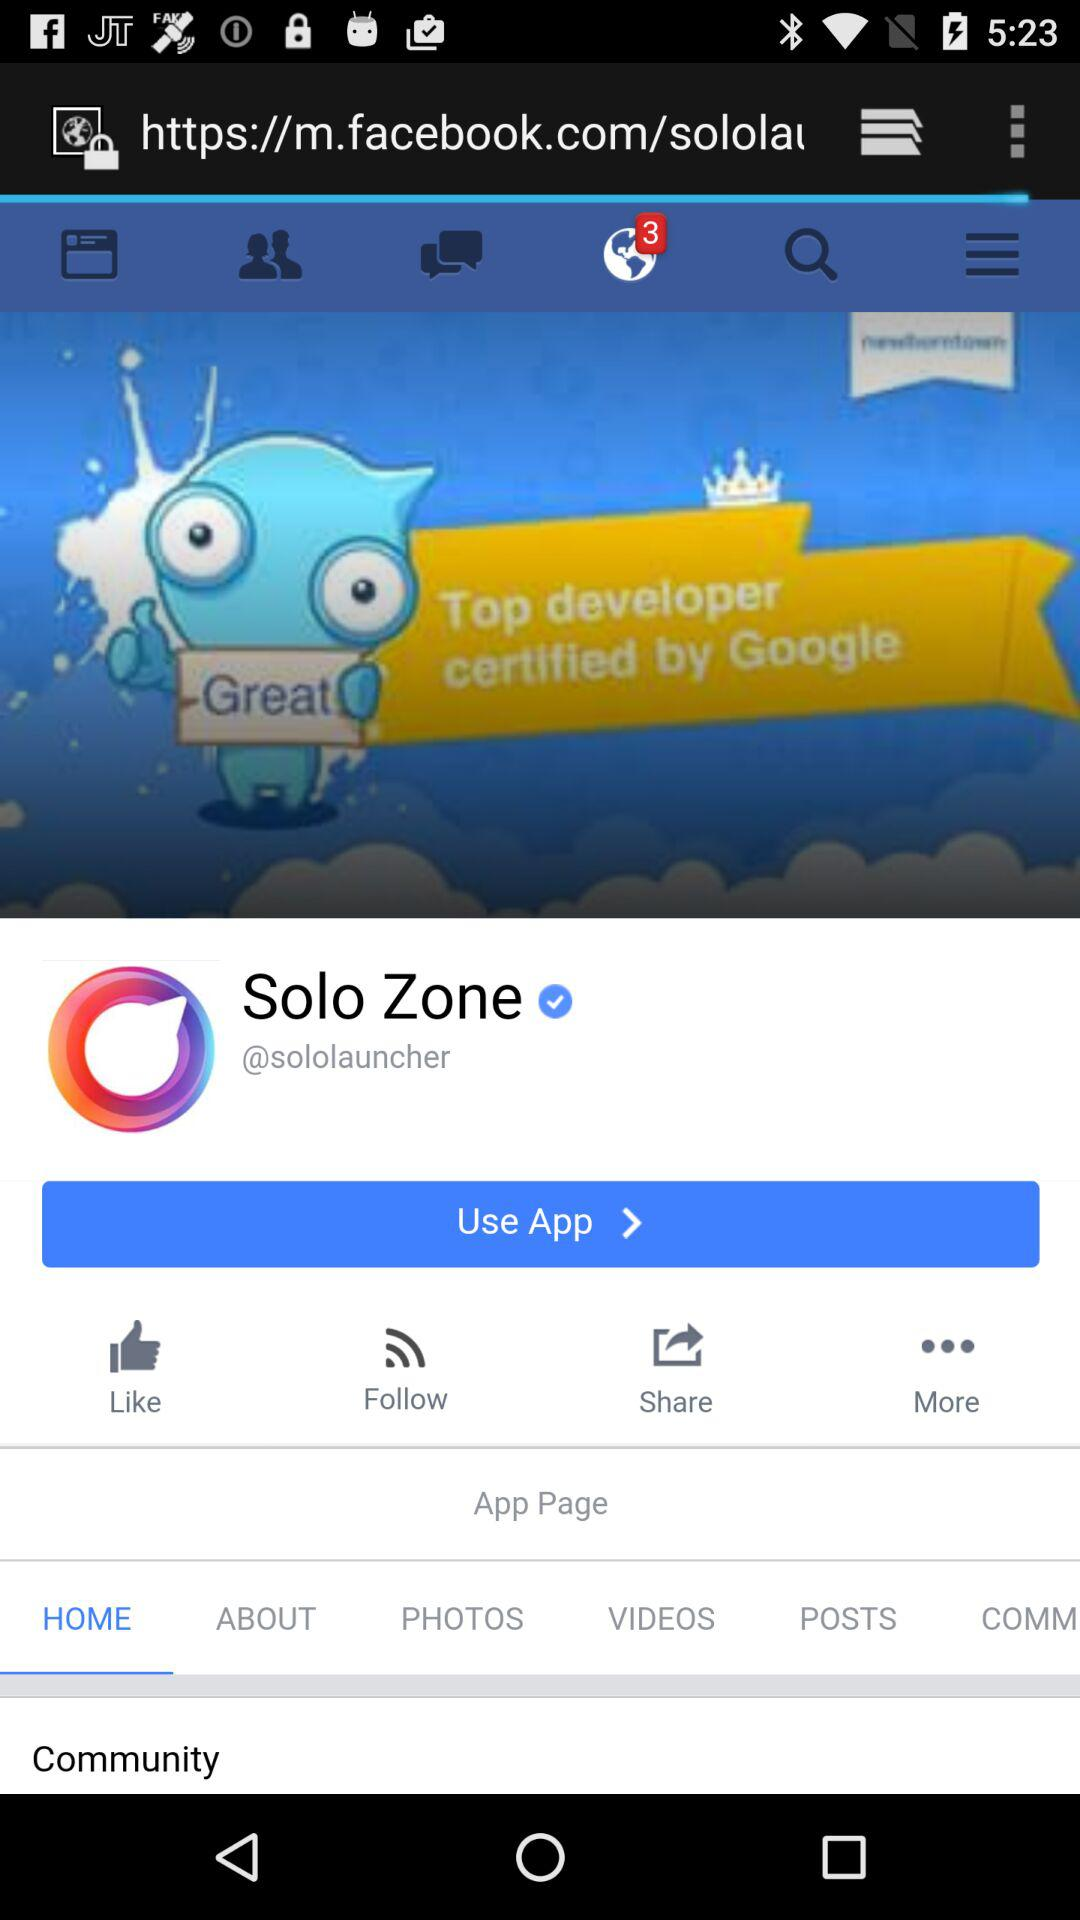How many unread notification is the app showing?
Answer the question using a single word or phrase. The number of unread notifications is 3 